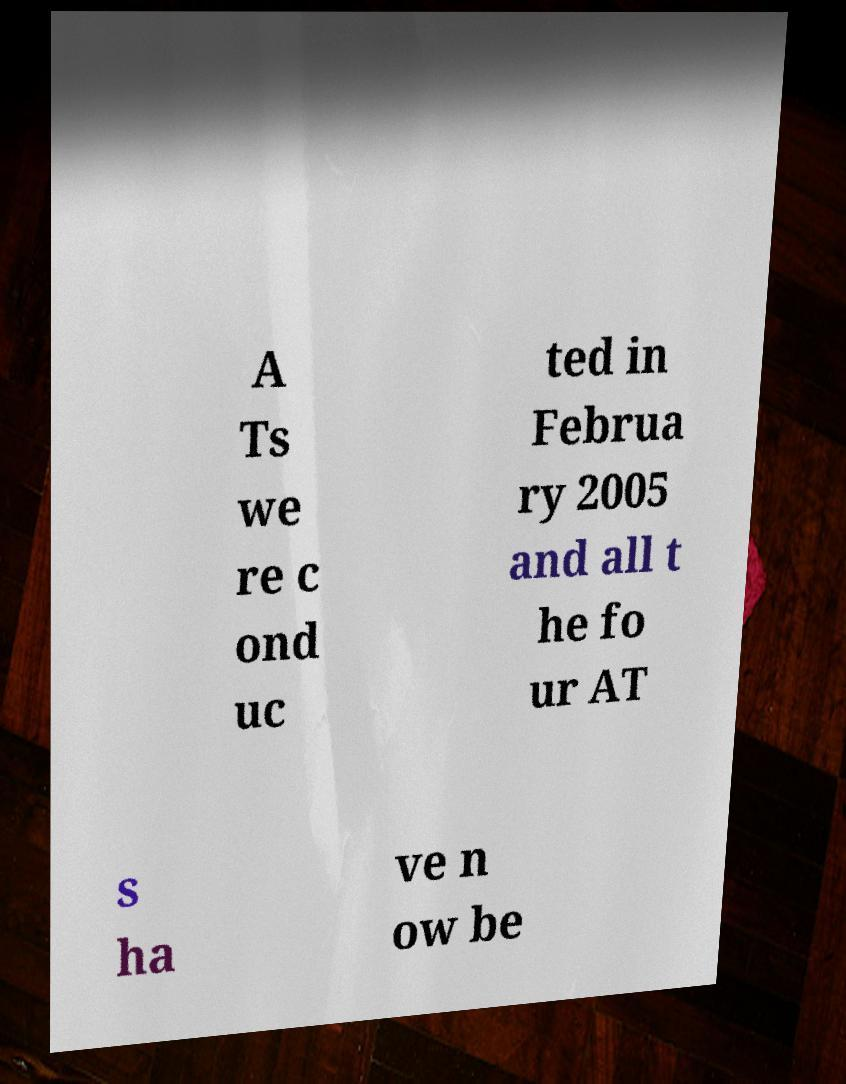Please read and relay the text visible in this image. What does it say? A Ts we re c ond uc ted in Februa ry 2005 and all t he fo ur AT s ha ve n ow be 